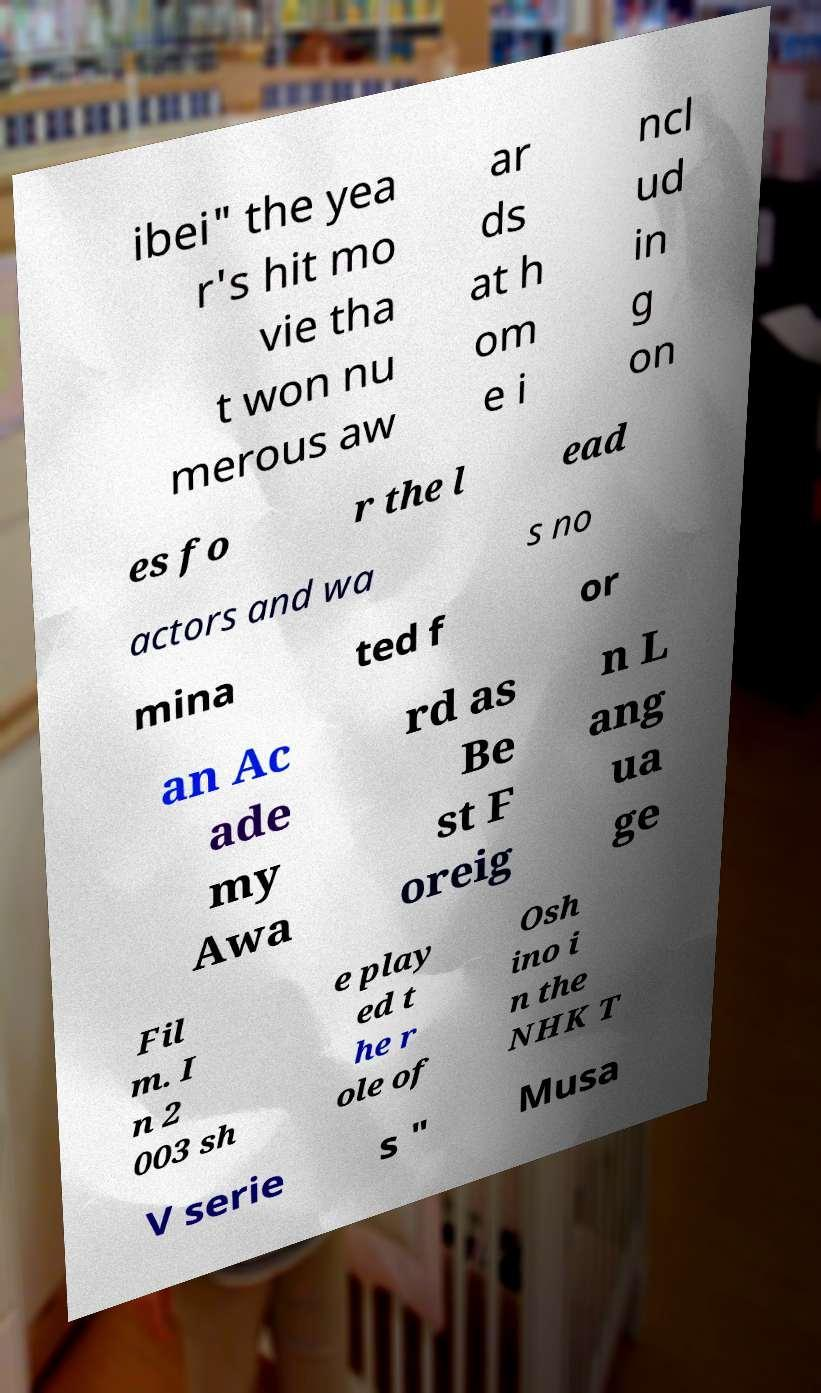Please identify and transcribe the text found in this image. ibei" the yea r's hit mo vie tha t won nu merous aw ar ds at h om e i ncl ud in g on es fo r the l ead actors and wa s no mina ted f or an Ac ade my Awa rd as Be st F oreig n L ang ua ge Fil m. I n 2 003 sh e play ed t he r ole of Osh ino i n the NHK T V serie s " Musa 